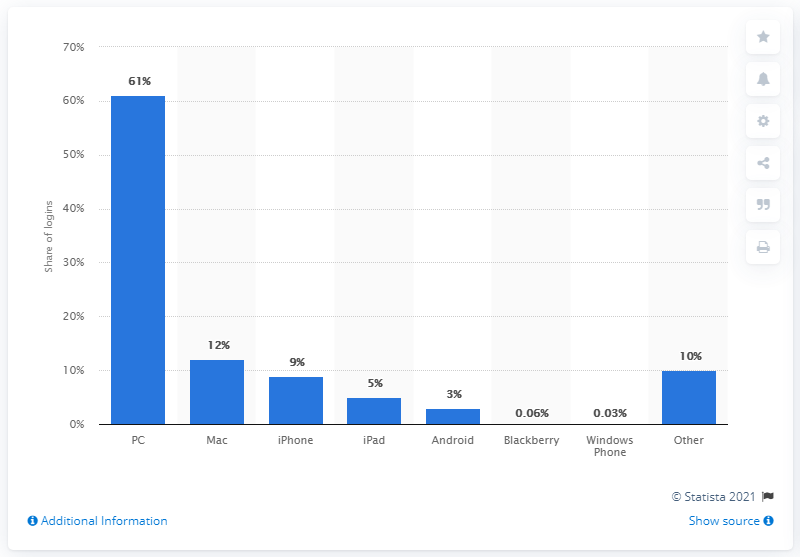Outline some significant characteristics in this image. During the survey period, iPhone users worldwide accounted for approximately 9% of social logins. 